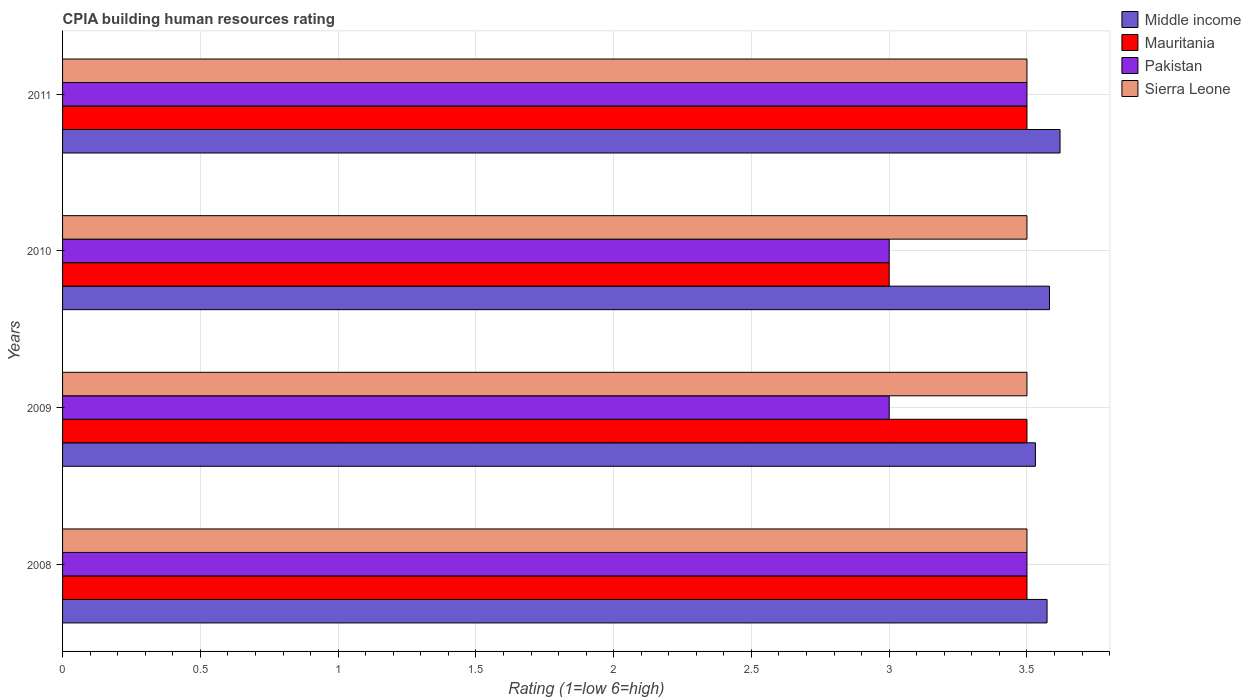How many different coloured bars are there?
Your answer should be compact. 4. How many groups of bars are there?
Give a very brief answer. 4. Are the number of bars on each tick of the Y-axis equal?
Ensure brevity in your answer.  Yes. How many bars are there on the 4th tick from the bottom?
Give a very brief answer. 4. In how many cases, is the number of bars for a given year not equal to the number of legend labels?
Make the answer very short. 0. What is the CPIA rating in Middle income in 2010?
Provide a short and direct response. 3.58. Across all years, what is the maximum CPIA rating in Pakistan?
Offer a terse response. 3.5. Across all years, what is the minimum CPIA rating in Pakistan?
Keep it short and to the point. 3. In which year was the CPIA rating in Middle income maximum?
Offer a very short reply. 2011. What is the difference between the CPIA rating in Middle income in 2010 and the CPIA rating in Pakistan in 2009?
Provide a short and direct response. 0.58. What is the average CPIA rating in Pakistan per year?
Your answer should be compact. 3.25. In the year 2009, what is the difference between the CPIA rating in Sierra Leone and CPIA rating in Middle income?
Your response must be concise. -0.03. In how many years, is the CPIA rating in Sierra Leone greater than 1.5 ?
Your answer should be very brief. 4. What is the ratio of the CPIA rating in Pakistan in 2008 to that in 2010?
Ensure brevity in your answer.  1.17. Is the CPIA rating in Mauritania in 2008 less than that in 2009?
Provide a succinct answer. No. Is the difference between the CPIA rating in Sierra Leone in 2008 and 2009 greater than the difference between the CPIA rating in Middle income in 2008 and 2009?
Your answer should be very brief. No. What is the difference between the highest and the lowest CPIA rating in Middle income?
Your answer should be very brief. 0.09. In how many years, is the CPIA rating in Sierra Leone greater than the average CPIA rating in Sierra Leone taken over all years?
Your answer should be very brief. 0. Is the sum of the CPIA rating in Pakistan in 2009 and 2011 greater than the maximum CPIA rating in Mauritania across all years?
Your answer should be very brief. Yes. Is it the case that in every year, the sum of the CPIA rating in Pakistan and CPIA rating in Middle income is greater than the sum of CPIA rating in Mauritania and CPIA rating in Sierra Leone?
Offer a very short reply. No. What does the 4th bar from the bottom in 2009 represents?
Provide a short and direct response. Sierra Leone. Is it the case that in every year, the sum of the CPIA rating in Middle income and CPIA rating in Pakistan is greater than the CPIA rating in Sierra Leone?
Keep it short and to the point. Yes. How many bars are there?
Ensure brevity in your answer.  16. How many years are there in the graph?
Provide a short and direct response. 4. Are the values on the major ticks of X-axis written in scientific E-notation?
Your response must be concise. No. Does the graph contain any zero values?
Make the answer very short. No. How are the legend labels stacked?
Give a very brief answer. Vertical. What is the title of the graph?
Ensure brevity in your answer.  CPIA building human resources rating. Does "India" appear as one of the legend labels in the graph?
Your answer should be compact. No. What is the label or title of the Y-axis?
Your answer should be very brief. Years. What is the Rating (1=low 6=high) of Middle income in 2008?
Offer a terse response. 3.57. What is the Rating (1=low 6=high) of Pakistan in 2008?
Provide a short and direct response. 3.5. What is the Rating (1=low 6=high) in Sierra Leone in 2008?
Offer a very short reply. 3.5. What is the Rating (1=low 6=high) in Middle income in 2009?
Ensure brevity in your answer.  3.53. What is the Rating (1=low 6=high) in Middle income in 2010?
Provide a succinct answer. 3.58. What is the Rating (1=low 6=high) in Mauritania in 2010?
Provide a short and direct response. 3. What is the Rating (1=low 6=high) in Pakistan in 2010?
Your answer should be compact. 3. What is the Rating (1=low 6=high) in Middle income in 2011?
Keep it short and to the point. 3.62. What is the Rating (1=low 6=high) in Mauritania in 2011?
Your answer should be very brief. 3.5. What is the Rating (1=low 6=high) of Pakistan in 2011?
Provide a succinct answer. 3.5. What is the Rating (1=low 6=high) of Sierra Leone in 2011?
Keep it short and to the point. 3.5. Across all years, what is the maximum Rating (1=low 6=high) of Middle income?
Provide a short and direct response. 3.62. Across all years, what is the maximum Rating (1=low 6=high) of Mauritania?
Keep it short and to the point. 3.5. Across all years, what is the minimum Rating (1=low 6=high) in Middle income?
Your response must be concise. 3.53. What is the total Rating (1=low 6=high) in Middle income in the graph?
Provide a short and direct response. 14.31. What is the total Rating (1=low 6=high) of Pakistan in the graph?
Offer a terse response. 13. What is the total Rating (1=low 6=high) in Sierra Leone in the graph?
Offer a very short reply. 14. What is the difference between the Rating (1=low 6=high) in Middle income in 2008 and that in 2009?
Give a very brief answer. 0.04. What is the difference between the Rating (1=low 6=high) of Pakistan in 2008 and that in 2009?
Give a very brief answer. 0.5. What is the difference between the Rating (1=low 6=high) in Middle income in 2008 and that in 2010?
Offer a very short reply. -0.01. What is the difference between the Rating (1=low 6=high) of Mauritania in 2008 and that in 2010?
Your answer should be very brief. 0.5. What is the difference between the Rating (1=low 6=high) of Sierra Leone in 2008 and that in 2010?
Make the answer very short. 0. What is the difference between the Rating (1=low 6=high) in Middle income in 2008 and that in 2011?
Your response must be concise. -0.05. What is the difference between the Rating (1=low 6=high) in Mauritania in 2008 and that in 2011?
Your answer should be compact. 0. What is the difference between the Rating (1=low 6=high) in Pakistan in 2008 and that in 2011?
Your answer should be very brief. 0. What is the difference between the Rating (1=low 6=high) of Sierra Leone in 2008 and that in 2011?
Make the answer very short. 0. What is the difference between the Rating (1=low 6=high) in Middle income in 2009 and that in 2010?
Give a very brief answer. -0.05. What is the difference between the Rating (1=low 6=high) of Middle income in 2009 and that in 2011?
Ensure brevity in your answer.  -0.09. What is the difference between the Rating (1=low 6=high) of Mauritania in 2009 and that in 2011?
Provide a succinct answer. 0. What is the difference between the Rating (1=low 6=high) of Pakistan in 2009 and that in 2011?
Your answer should be very brief. -0.5. What is the difference between the Rating (1=low 6=high) of Sierra Leone in 2009 and that in 2011?
Your response must be concise. 0. What is the difference between the Rating (1=low 6=high) of Middle income in 2010 and that in 2011?
Provide a short and direct response. -0.04. What is the difference between the Rating (1=low 6=high) of Mauritania in 2010 and that in 2011?
Keep it short and to the point. -0.5. What is the difference between the Rating (1=low 6=high) in Sierra Leone in 2010 and that in 2011?
Provide a short and direct response. 0. What is the difference between the Rating (1=low 6=high) in Middle income in 2008 and the Rating (1=low 6=high) in Mauritania in 2009?
Make the answer very short. 0.07. What is the difference between the Rating (1=low 6=high) in Middle income in 2008 and the Rating (1=low 6=high) in Pakistan in 2009?
Offer a terse response. 0.57. What is the difference between the Rating (1=low 6=high) in Middle income in 2008 and the Rating (1=low 6=high) in Sierra Leone in 2009?
Your response must be concise. 0.07. What is the difference between the Rating (1=low 6=high) in Mauritania in 2008 and the Rating (1=low 6=high) in Pakistan in 2009?
Your answer should be compact. 0.5. What is the difference between the Rating (1=low 6=high) of Pakistan in 2008 and the Rating (1=low 6=high) of Sierra Leone in 2009?
Give a very brief answer. 0. What is the difference between the Rating (1=low 6=high) in Middle income in 2008 and the Rating (1=low 6=high) in Mauritania in 2010?
Your response must be concise. 0.57. What is the difference between the Rating (1=low 6=high) in Middle income in 2008 and the Rating (1=low 6=high) in Pakistan in 2010?
Your answer should be compact. 0.57. What is the difference between the Rating (1=low 6=high) of Middle income in 2008 and the Rating (1=low 6=high) of Sierra Leone in 2010?
Keep it short and to the point. 0.07. What is the difference between the Rating (1=low 6=high) of Middle income in 2008 and the Rating (1=low 6=high) of Mauritania in 2011?
Offer a very short reply. 0.07. What is the difference between the Rating (1=low 6=high) in Middle income in 2008 and the Rating (1=low 6=high) in Pakistan in 2011?
Offer a very short reply. 0.07. What is the difference between the Rating (1=low 6=high) in Middle income in 2008 and the Rating (1=low 6=high) in Sierra Leone in 2011?
Provide a succinct answer. 0.07. What is the difference between the Rating (1=low 6=high) in Mauritania in 2008 and the Rating (1=low 6=high) in Pakistan in 2011?
Your response must be concise. 0. What is the difference between the Rating (1=low 6=high) in Mauritania in 2008 and the Rating (1=low 6=high) in Sierra Leone in 2011?
Give a very brief answer. 0. What is the difference between the Rating (1=low 6=high) of Middle income in 2009 and the Rating (1=low 6=high) of Mauritania in 2010?
Ensure brevity in your answer.  0.53. What is the difference between the Rating (1=low 6=high) of Middle income in 2009 and the Rating (1=low 6=high) of Pakistan in 2010?
Your answer should be compact. 0.53. What is the difference between the Rating (1=low 6=high) of Middle income in 2009 and the Rating (1=low 6=high) of Sierra Leone in 2010?
Provide a succinct answer. 0.03. What is the difference between the Rating (1=low 6=high) of Mauritania in 2009 and the Rating (1=low 6=high) of Pakistan in 2010?
Make the answer very short. 0.5. What is the difference between the Rating (1=low 6=high) of Mauritania in 2009 and the Rating (1=low 6=high) of Sierra Leone in 2010?
Your answer should be compact. 0. What is the difference between the Rating (1=low 6=high) in Middle income in 2009 and the Rating (1=low 6=high) in Mauritania in 2011?
Your answer should be compact. 0.03. What is the difference between the Rating (1=low 6=high) of Middle income in 2009 and the Rating (1=low 6=high) of Pakistan in 2011?
Provide a short and direct response. 0.03. What is the difference between the Rating (1=low 6=high) of Middle income in 2009 and the Rating (1=low 6=high) of Sierra Leone in 2011?
Provide a succinct answer. 0.03. What is the difference between the Rating (1=low 6=high) in Mauritania in 2009 and the Rating (1=low 6=high) in Sierra Leone in 2011?
Ensure brevity in your answer.  0. What is the difference between the Rating (1=low 6=high) in Middle income in 2010 and the Rating (1=low 6=high) in Mauritania in 2011?
Your answer should be compact. 0.08. What is the difference between the Rating (1=low 6=high) in Middle income in 2010 and the Rating (1=low 6=high) in Pakistan in 2011?
Ensure brevity in your answer.  0.08. What is the difference between the Rating (1=low 6=high) in Middle income in 2010 and the Rating (1=low 6=high) in Sierra Leone in 2011?
Make the answer very short. 0.08. What is the difference between the Rating (1=low 6=high) of Mauritania in 2010 and the Rating (1=low 6=high) of Sierra Leone in 2011?
Ensure brevity in your answer.  -0.5. What is the average Rating (1=low 6=high) of Middle income per year?
Give a very brief answer. 3.58. What is the average Rating (1=low 6=high) in Mauritania per year?
Keep it short and to the point. 3.38. What is the average Rating (1=low 6=high) of Pakistan per year?
Offer a very short reply. 3.25. What is the average Rating (1=low 6=high) of Sierra Leone per year?
Provide a short and direct response. 3.5. In the year 2008, what is the difference between the Rating (1=low 6=high) in Middle income and Rating (1=low 6=high) in Mauritania?
Your answer should be compact. 0.07. In the year 2008, what is the difference between the Rating (1=low 6=high) of Middle income and Rating (1=low 6=high) of Pakistan?
Offer a terse response. 0.07. In the year 2008, what is the difference between the Rating (1=low 6=high) in Middle income and Rating (1=low 6=high) in Sierra Leone?
Your answer should be very brief. 0.07. In the year 2008, what is the difference between the Rating (1=low 6=high) of Mauritania and Rating (1=low 6=high) of Pakistan?
Your answer should be compact. 0. In the year 2008, what is the difference between the Rating (1=low 6=high) of Pakistan and Rating (1=low 6=high) of Sierra Leone?
Provide a succinct answer. 0. In the year 2009, what is the difference between the Rating (1=low 6=high) in Middle income and Rating (1=low 6=high) in Mauritania?
Offer a terse response. 0.03. In the year 2009, what is the difference between the Rating (1=low 6=high) of Middle income and Rating (1=low 6=high) of Pakistan?
Your answer should be compact. 0.53. In the year 2009, what is the difference between the Rating (1=low 6=high) in Middle income and Rating (1=low 6=high) in Sierra Leone?
Keep it short and to the point. 0.03. In the year 2009, what is the difference between the Rating (1=low 6=high) in Mauritania and Rating (1=low 6=high) in Sierra Leone?
Ensure brevity in your answer.  0. In the year 2009, what is the difference between the Rating (1=low 6=high) of Pakistan and Rating (1=low 6=high) of Sierra Leone?
Provide a succinct answer. -0.5. In the year 2010, what is the difference between the Rating (1=low 6=high) in Middle income and Rating (1=low 6=high) in Mauritania?
Ensure brevity in your answer.  0.58. In the year 2010, what is the difference between the Rating (1=low 6=high) in Middle income and Rating (1=low 6=high) in Pakistan?
Offer a very short reply. 0.58. In the year 2010, what is the difference between the Rating (1=low 6=high) of Middle income and Rating (1=low 6=high) of Sierra Leone?
Your answer should be compact. 0.08. In the year 2010, what is the difference between the Rating (1=low 6=high) of Mauritania and Rating (1=low 6=high) of Sierra Leone?
Your answer should be very brief. -0.5. In the year 2010, what is the difference between the Rating (1=low 6=high) in Pakistan and Rating (1=low 6=high) in Sierra Leone?
Offer a very short reply. -0.5. In the year 2011, what is the difference between the Rating (1=low 6=high) in Middle income and Rating (1=low 6=high) in Mauritania?
Your answer should be very brief. 0.12. In the year 2011, what is the difference between the Rating (1=low 6=high) in Middle income and Rating (1=low 6=high) in Pakistan?
Your answer should be compact. 0.12. In the year 2011, what is the difference between the Rating (1=low 6=high) of Middle income and Rating (1=low 6=high) of Sierra Leone?
Ensure brevity in your answer.  0.12. In the year 2011, what is the difference between the Rating (1=low 6=high) of Mauritania and Rating (1=low 6=high) of Sierra Leone?
Offer a very short reply. 0. What is the ratio of the Rating (1=low 6=high) of Pakistan in 2008 to that in 2009?
Keep it short and to the point. 1.17. What is the ratio of the Rating (1=low 6=high) in Pakistan in 2008 to that in 2010?
Give a very brief answer. 1.17. What is the ratio of the Rating (1=low 6=high) in Middle income in 2008 to that in 2011?
Provide a short and direct response. 0.99. What is the ratio of the Rating (1=low 6=high) of Pakistan in 2008 to that in 2011?
Your answer should be compact. 1. What is the ratio of the Rating (1=low 6=high) of Middle income in 2009 to that in 2010?
Give a very brief answer. 0.99. What is the ratio of the Rating (1=low 6=high) in Pakistan in 2009 to that in 2010?
Make the answer very short. 1. What is the ratio of the Rating (1=low 6=high) of Middle income in 2009 to that in 2011?
Offer a very short reply. 0.98. What is the ratio of the Rating (1=low 6=high) of Sierra Leone in 2009 to that in 2011?
Give a very brief answer. 1. What is the ratio of the Rating (1=low 6=high) of Pakistan in 2010 to that in 2011?
Your response must be concise. 0.86. What is the ratio of the Rating (1=low 6=high) of Sierra Leone in 2010 to that in 2011?
Make the answer very short. 1. What is the difference between the highest and the second highest Rating (1=low 6=high) in Middle income?
Ensure brevity in your answer.  0.04. What is the difference between the highest and the lowest Rating (1=low 6=high) in Middle income?
Offer a very short reply. 0.09. What is the difference between the highest and the lowest Rating (1=low 6=high) of Sierra Leone?
Provide a short and direct response. 0. 